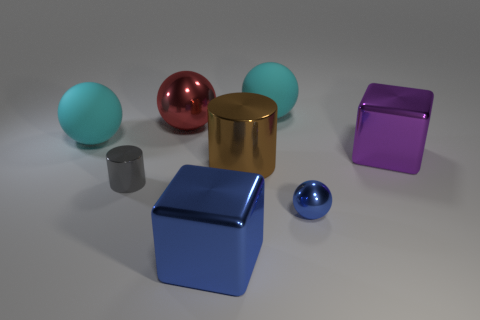Is the number of large purple shiny things less than the number of large yellow cylinders?
Your response must be concise. No. What number of cylinders are either red things or purple shiny objects?
Keep it short and to the point. 0. How many shiny objects are the same color as the small metallic ball?
Your answer should be very brief. 1. There is a metal object that is both to the left of the big purple thing and behind the large shiny cylinder; how big is it?
Your response must be concise. Large. Are there fewer small things that are right of the large cylinder than tiny blue things?
Provide a succinct answer. No. Are the large brown thing and the tiny cylinder made of the same material?
Ensure brevity in your answer.  Yes. How many things are large red rubber cubes or small gray shiny things?
Provide a succinct answer. 1. How many blue cubes are made of the same material as the small blue thing?
Ensure brevity in your answer.  1. There is a brown object that is the same shape as the gray thing; what size is it?
Keep it short and to the point. Large. There is a big red ball; are there any gray cylinders to the right of it?
Keep it short and to the point. No. 